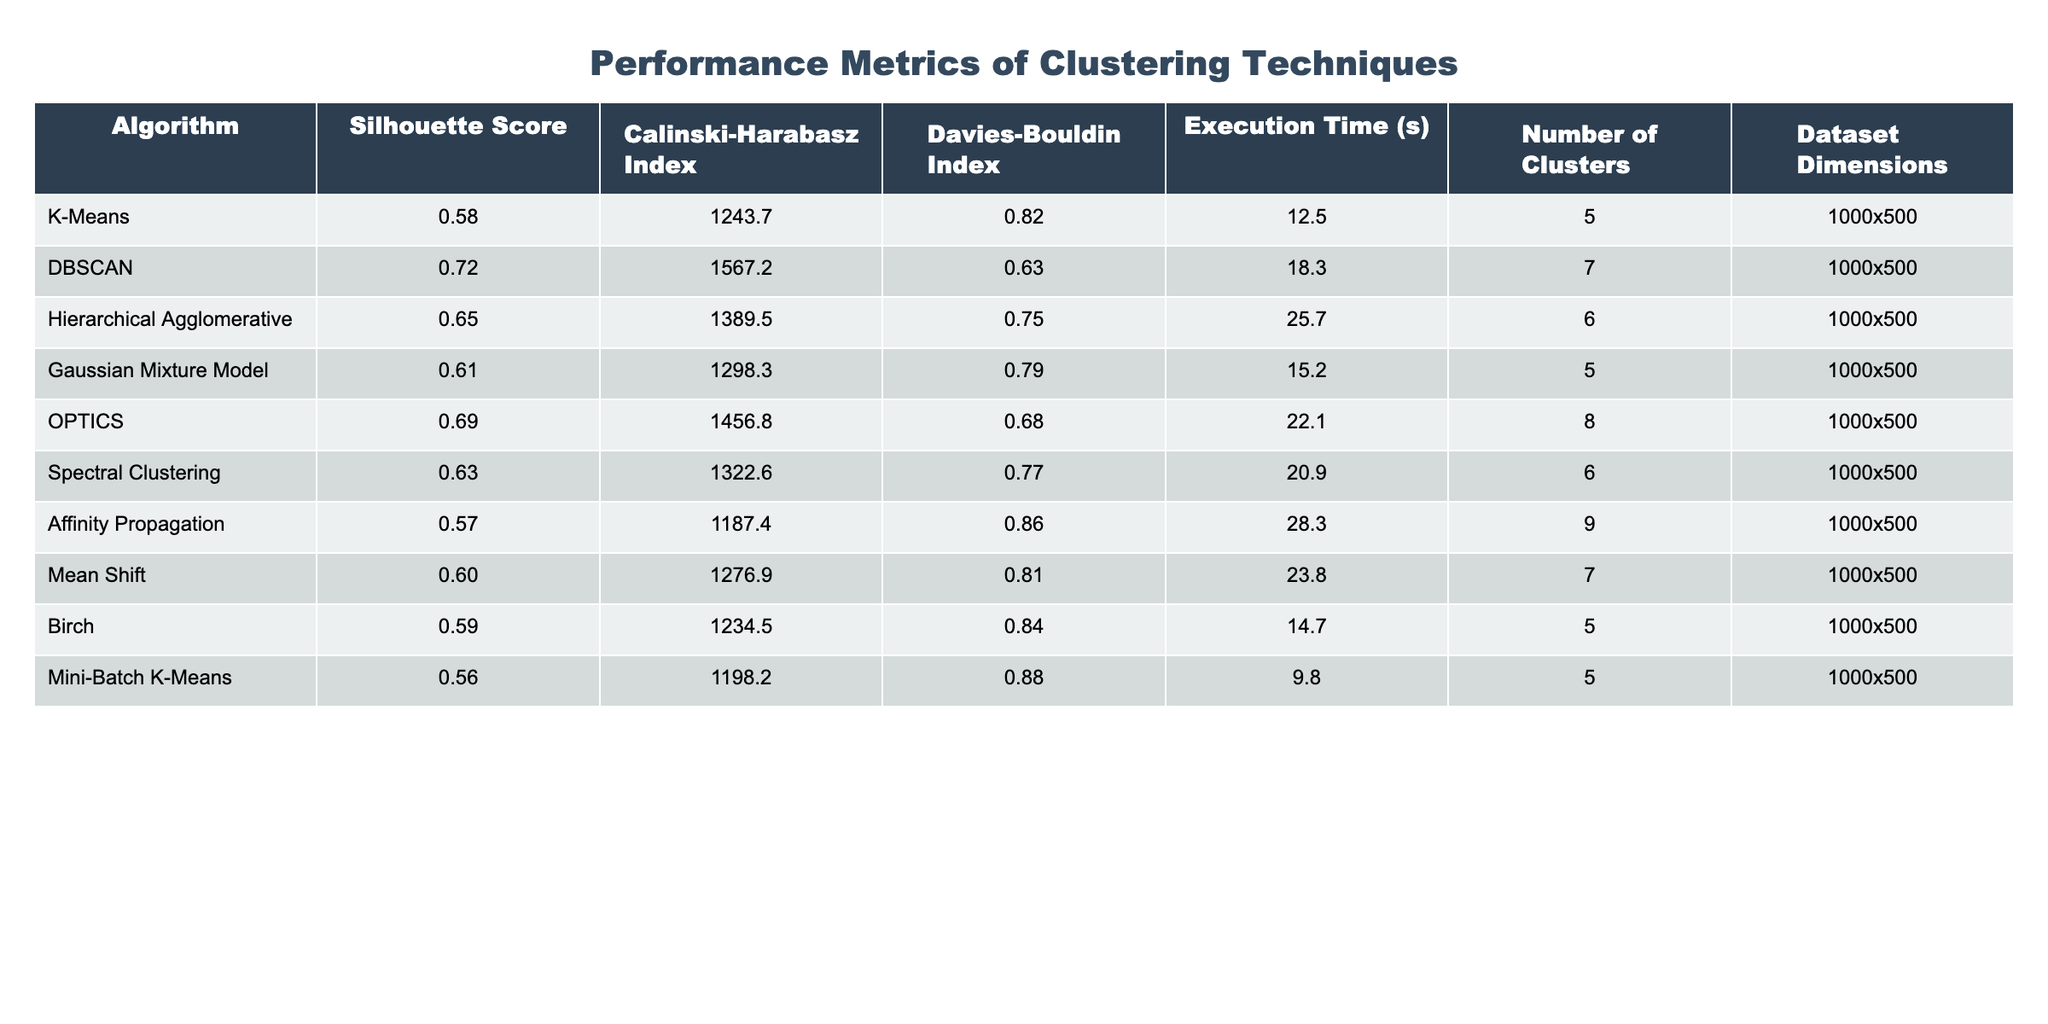What is the Silhouette Score for DBSCAN? The table shows that the Silhouette Score for the DBSCAN algorithm is 0.72, which is the corresponding value in the column for DBSCAN.
Answer: 0.72 Which clustering algorithm has the highest Calinski-Harabasz Index? Looking at the Calinski-Harabasz Index column, DBSCAN has the highest value of 1567.2 compared to the other algorithms listed.
Answer: DBSCAN What is the Davies-Bouldin Index of Mean Shift? According to the table, the Davies-Bouldin Index for Mean Shift is 0.81, which can be found in the corresponding row for Mean Shift.
Answer: 0.81 How many clusters does the Gaussian Mixture Model use? The table shows that the Gaussian Mixture Model uses 5 clusters, which is listed in the "Number of Clusters" column for that algorithm.
Answer: 5 Which algorithm has the longest execution time and what is it? By examining the Execution Time column, we can see that Affinity Propagation has the longest execution time of 28.3 seconds.
Answer: 28.3 seconds What is the average Silhouette Score of all algorithms listed? The Silhouette Scores are: 0.58, 0.72, 0.65, 0.61, 0.69, 0.63, 0.57, 0.60, 0.59, and 0.56. Summing these gives 0.58 + 0.72 + 0.65 + 0.61 + 0.69 + 0.63 + 0.57 + 0.60 + 0.59 + 0.56 = 6.20. Dividing by 10 results in an average Silhouette Score of 0.62.
Answer: 0.62 Is the Execution Time for Hierarchical Agglomerative greater than that of K-Means? The Execution Time for Hierarchical Agglomerative is 25.7 seconds, while for K-Means, it is 12.5 seconds. Since 25.7 > 12.5, the statement is true.
Answer: Yes If we compare the Davies-Bouldin Index of OPTICS and DBSCAN, which one is lower? The Davies-Bouldin Index for OPTICS is 0.68 and for DBSCAN it is 0.63. Since 0.68 is greater than 0.63, DBSCAN has the lower index.
Answer: DBSCAN What is the difference in execution time between the fastest and slowest algorithms? The fastest algorithm is Mini-Batch K-Means with 9.8 seconds, and the slowest is Affinity Propagation with 28.3 seconds. The difference is 28.3 - 9.8 = 18.5 seconds.
Answer: 18.5 seconds Which algorithm has the lowest Davies-Bouldin Index? By examining the Davies-Bouldin Index column, DBSCAN (0.63) has the lowest value compared to the other algorithms listed.
Answer: DBSCAN Among the algorithms, which one shows the highest number of dimensions in the dataset? All algorithms are tested on a dataset with dimensions labeled as 1000x500, indicating that they all share the same high dimensionality.
Answer: All algorithms have the same dimensions: 1000x500 